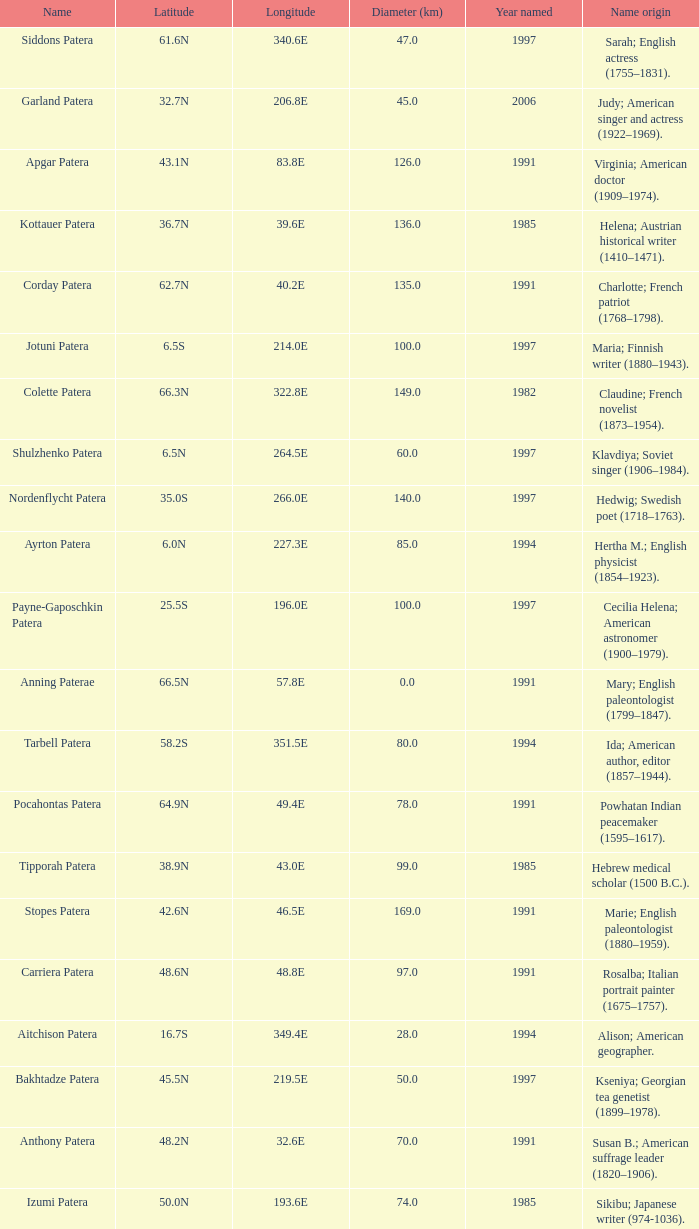What is  the diameter in km of the feature with a longitude of 40.2E?  135.0. 